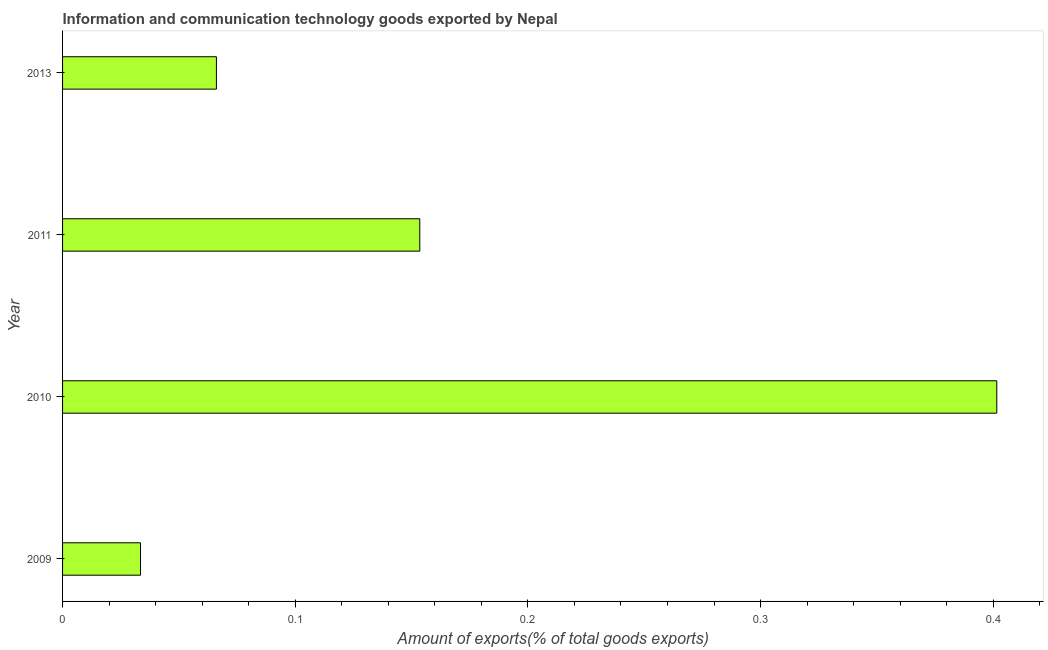Does the graph contain grids?
Your answer should be compact. No. What is the title of the graph?
Your answer should be very brief. Information and communication technology goods exported by Nepal. What is the label or title of the X-axis?
Provide a succinct answer. Amount of exports(% of total goods exports). What is the amount of ict goods exports in 2013?
Provide a short and direct response. 0.07. Across all years, what is the maximum amount of ict goods exports?
Make the answer very short. 0.4. Across all years, what is the minimum amount of ict goods exports?
Give a very brief answer. 0.03. In which year was the amount of ict goods exports maximum?
Your answer should be very brief. 2010. What is the sum of the amount of ict goods exports?
Offer a terse response. 0.65. What is the difference between the amount of ict goods exports in 2010 and 2011?
Your answer should be compact. 0.25. What is the average amount of ict goods exports per year?
Offer a very short reply. 0.16. What is the median amount of ict goods exports?
Offer a terse response. 0.11. Do a majority of the years between 2009 and 2013 (inclusive) have amount of ict goods exports greater than 0.14 %?
Provide a succinct answer. No. What is the ratio of the amount of ict goods exports in 2010 to that in 2011?
Offer a very short reply. 2.62. Is the amount of ict goods exports in 2009 less than that in 2011?
Your response must be concise. Yes. Is the difference between the amount of ict goods exports in 2009 and 2011 greater than the difference between any two years?
Offer a very short reply. No. What is the difference between the highest and the second highest amount of ict goods exports?
Ensure brevity in your answer.  0.25. What is the difference between the highest and the lowest amount of ict goods exports?
Ensure brevity in your answer.  0.37. What is the Amount of exports(% of total goods exports) of 2009?
Ensure brevity in your answer.  0.03. What is the Amount of exports(% of total goods exports) in 2010?
Provide a short and direct response. 0.4. What is the Amount of exports(% of total goods exports) of 2011?
Make the answer very short. 0.15. What is the Amount of exports(% of total goods exports) in 2013?
Your response must be concise. 0.07. What is the difference between the Amount of exports(% of total goods exports) in 2009 and 2010?
Give a very brief answer. -0.37. What is the difference between the Amount of exports(% of total goods exports) in 2009 and 2011?
Your response must be concise. -0.12. What is the difference between the Amount of exports(% of total goods exports) in 2009 and 2013?
Make the answer very short. -0.03. What is the difference between the Amount of exports(% of total goods exports) in 2010 and 2011?
Make the answer very short. 0.25. What is the difference between the Amount of exports(% of total goods exports) in 2010 and 2013?
Ensure brevity in your answer.  0.34. What is the difference between the Amount of exports(% of total goods exports) in 2011 and 2013?
Provide a succinct answer. 0.09. What is the ratio of the Amount of exports(% of total goods exports) in 2009 to that in 2010?
Give a very brief answer. 0.08. What is the ratio of the Amount of exports(% of total goods exports) in 2009 to that in 2011?
Your response must be concise. 0.22. What is the ratio of the Amount of exports(% of total goods exports) in 2009 to that in 2013?
Provide a short and direct response. 0.51. What is the ratio of the Amount of exports(% of total goods exports) in 2010 to that in 2011?
Offer a terse response. 2.62. What is the ratio of the Amount of exports(% of total goods exports) in 2010 to that in 2013?
Provide a short and direct response. 6.07. What is the ratio of the Amount of exports(% of total goods exports) in 2011 to that in 2013?
Your response must be concise. 2.32. 